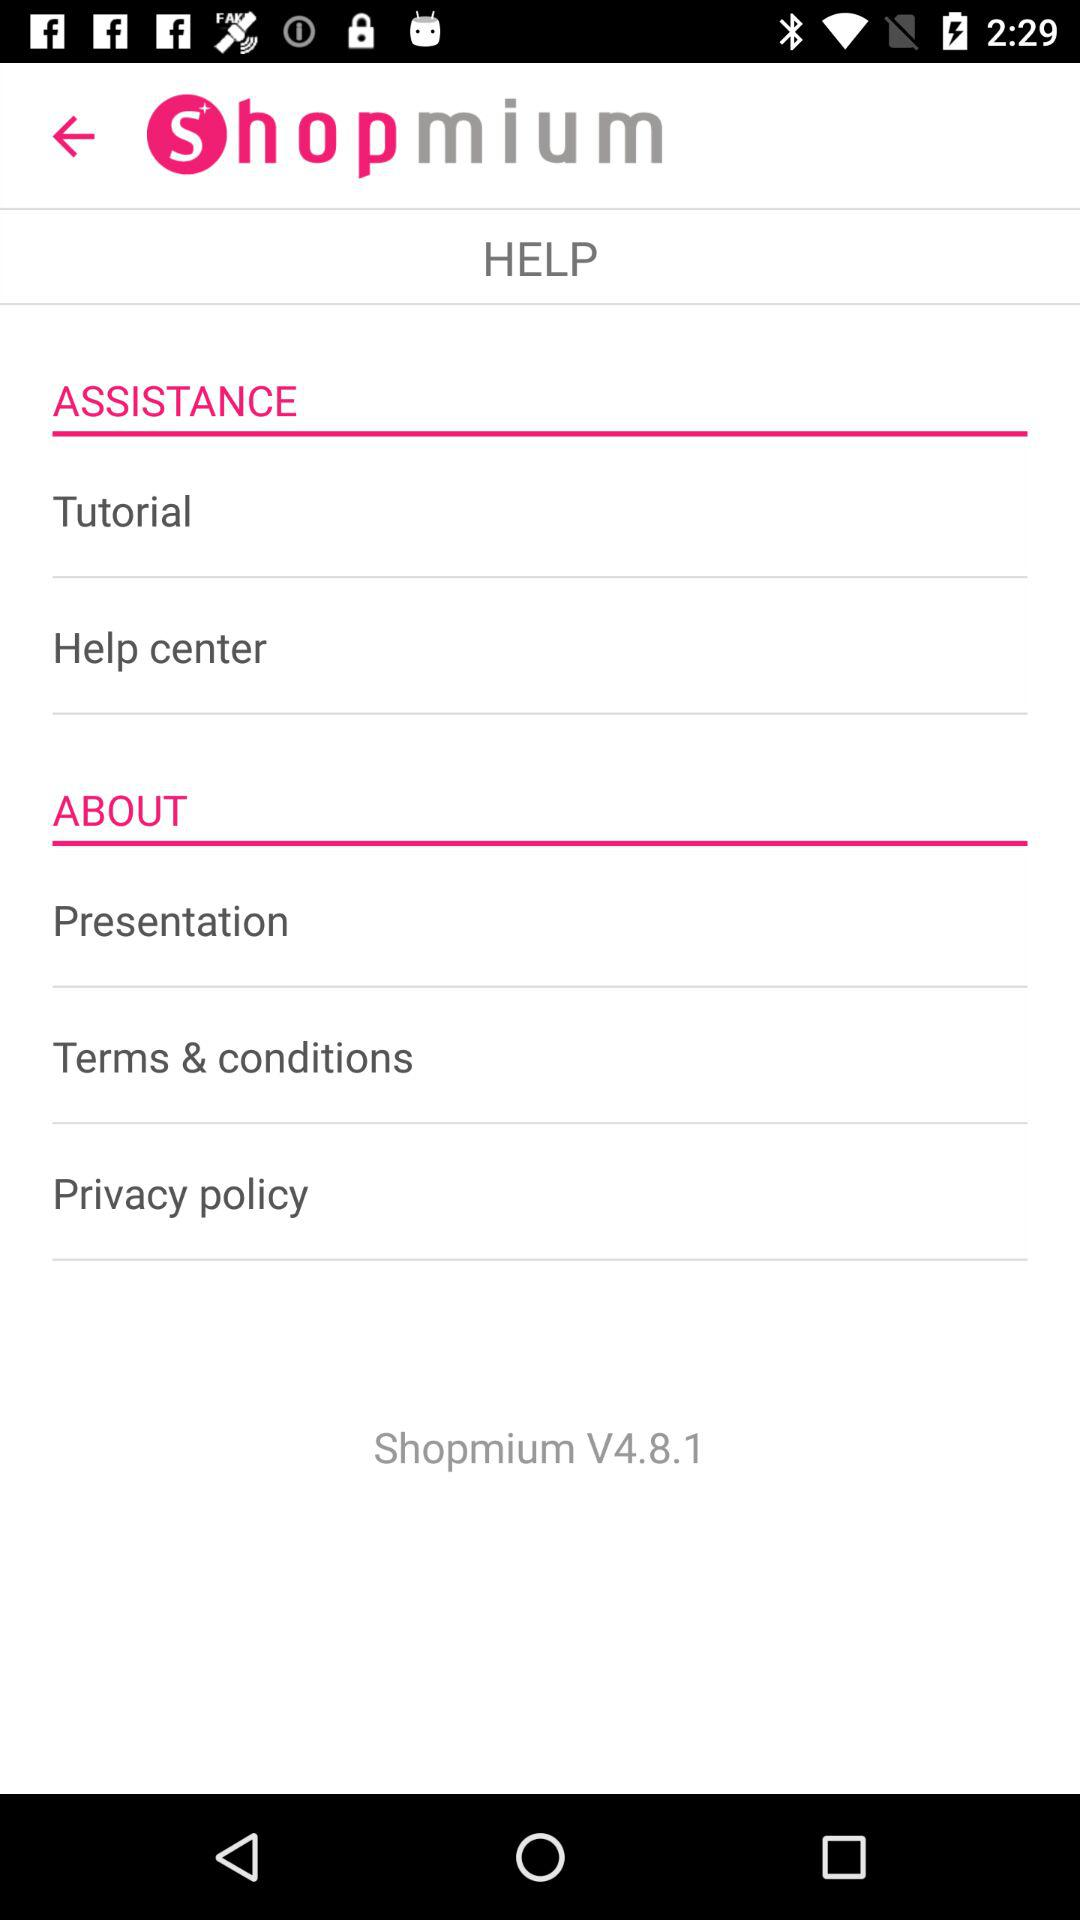What is the current version of Shopmium? The current version of Shopmium is 4.8.1. 